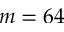<formula> <loc_0><loc_0><loc_500><loc_500>m = 6 4</formula> 